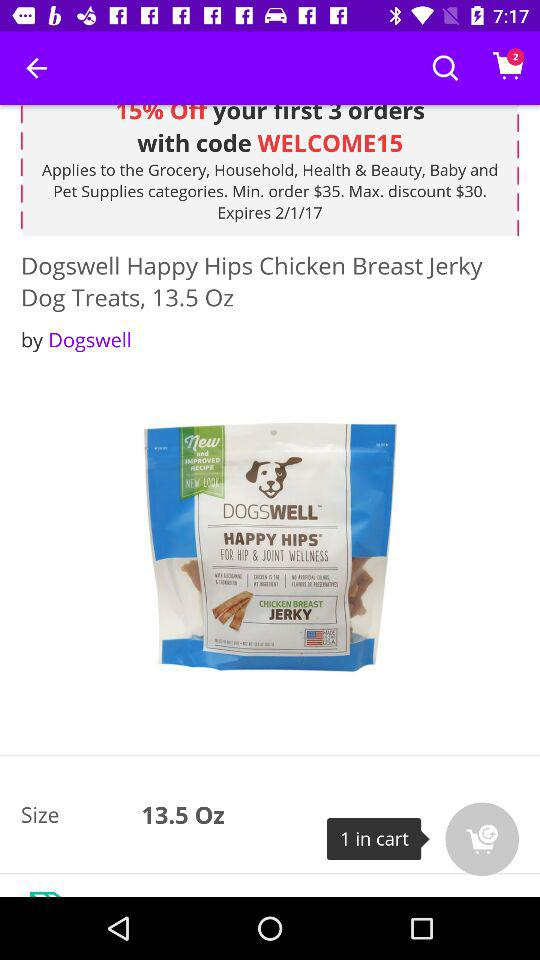How much is the discount?
Answer the question using a single word or phrase. 15% 